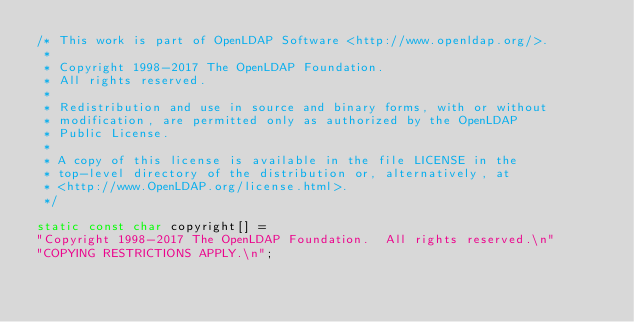Convert code to text. <code><loc_0><loc_0><loc_500><loc_500><_C_>/* This work is part of OpenLDAP Software <http://www.openldap.org/>.
 *
 * Copyright 1998-2017 The OpenLDAP Foundation.
 * All rights reserved.
 *
 * Redistribution and use in source and binary forms, with or without
 * modification, are permitted only as authorized by the OpenLDAP
 * Public License.
 * 
 * A copy of this license is available in the file LICENSE in the
 * top-level directory of the distribution or, alternatively, at
 * <http://www.OpenLDAP.org/license.html>.
 */

static const char copyright[] =
"Copyright 1998-2017 The OpenLDAP Foundation.  All rights reserved.\n"
"COPYING RESTRICTIONS APPLY.\n";

</code> 